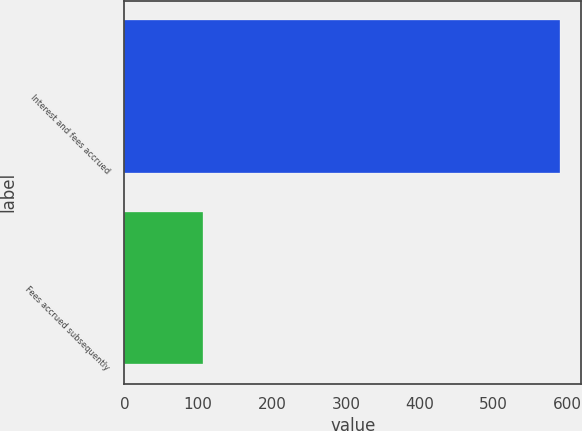Convert chart to OTSL. <chart><loc_0><loc_0><loc_500><loc_500><bar_chart><fcel>Interest and fees accrued<fcel>Fees accrued subsequently<nl><fcel>589<fcel>106<nl></chart> 